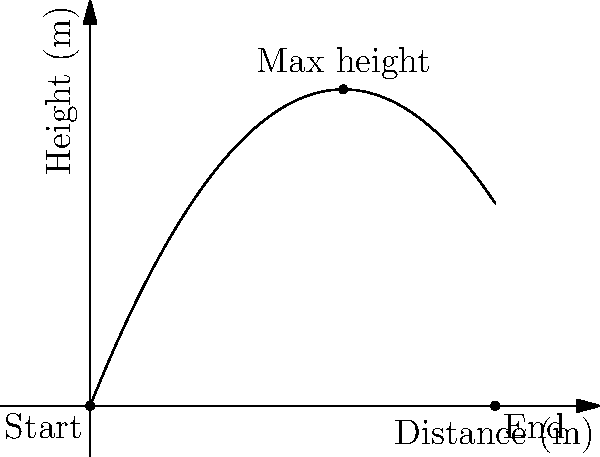In an AFL Women's match, a player kicks a football, and its trajectory can be modeled by the equation $h(x) = -0.2x^2 + 2.5x$, where $h$ is the height in meters and $x$ is the horizontal distance in meters. Determine the maximum height reached by the football and the total horizontal distance it travels before hitting the ground. To solve this problem, we'll follow these steps:

1. Find the maximum height:
   - The maximum height occurs at the vertex of the parabola.
   - For a quadratic equation in the form $f(x) = ax^2 + bx + c$, the x-coordinate of the vertex is given by $x = -\frac{b}{2a}$.
   - In our equation, $a = -0.2$ and $b = 2.5$.
   - $x = -\frac{2.5}{2(-0.2)} = \frac{2.5}{0.4} = 6.25$ meters

2. Calculate the maximum height:
   - Substitute $x = 6.25$ into the original equation:
   - $h(6.25) = -0.2(6.25)^2 + 2.5(6.25)$
   - $h(6.25) = -0.2(39.0625) + 15.625$
   - $h(6.25) = -7.8125 + 15.625 = 7.8125$ meters

3. Find the total horizontal distance:
   - The football hits the ground when $h(x) = 0$.
   - Solve the equation: $0 = -0.2x^2 + 2.5x$
   - Factor out x: $x(-0.2x + 2.5) = 0$
   - Solutions: $x = 0$ or $x = 12.5$
   - The non-zero solution (12.5) represents the total horizontal distance.

Therefore, the maximum height reached is 7.8125 meters, and the total horizontal distance traveled is 12.5 meters.
Answer: Maximum height: 7.8125 m; Total distance: 12.5 m 